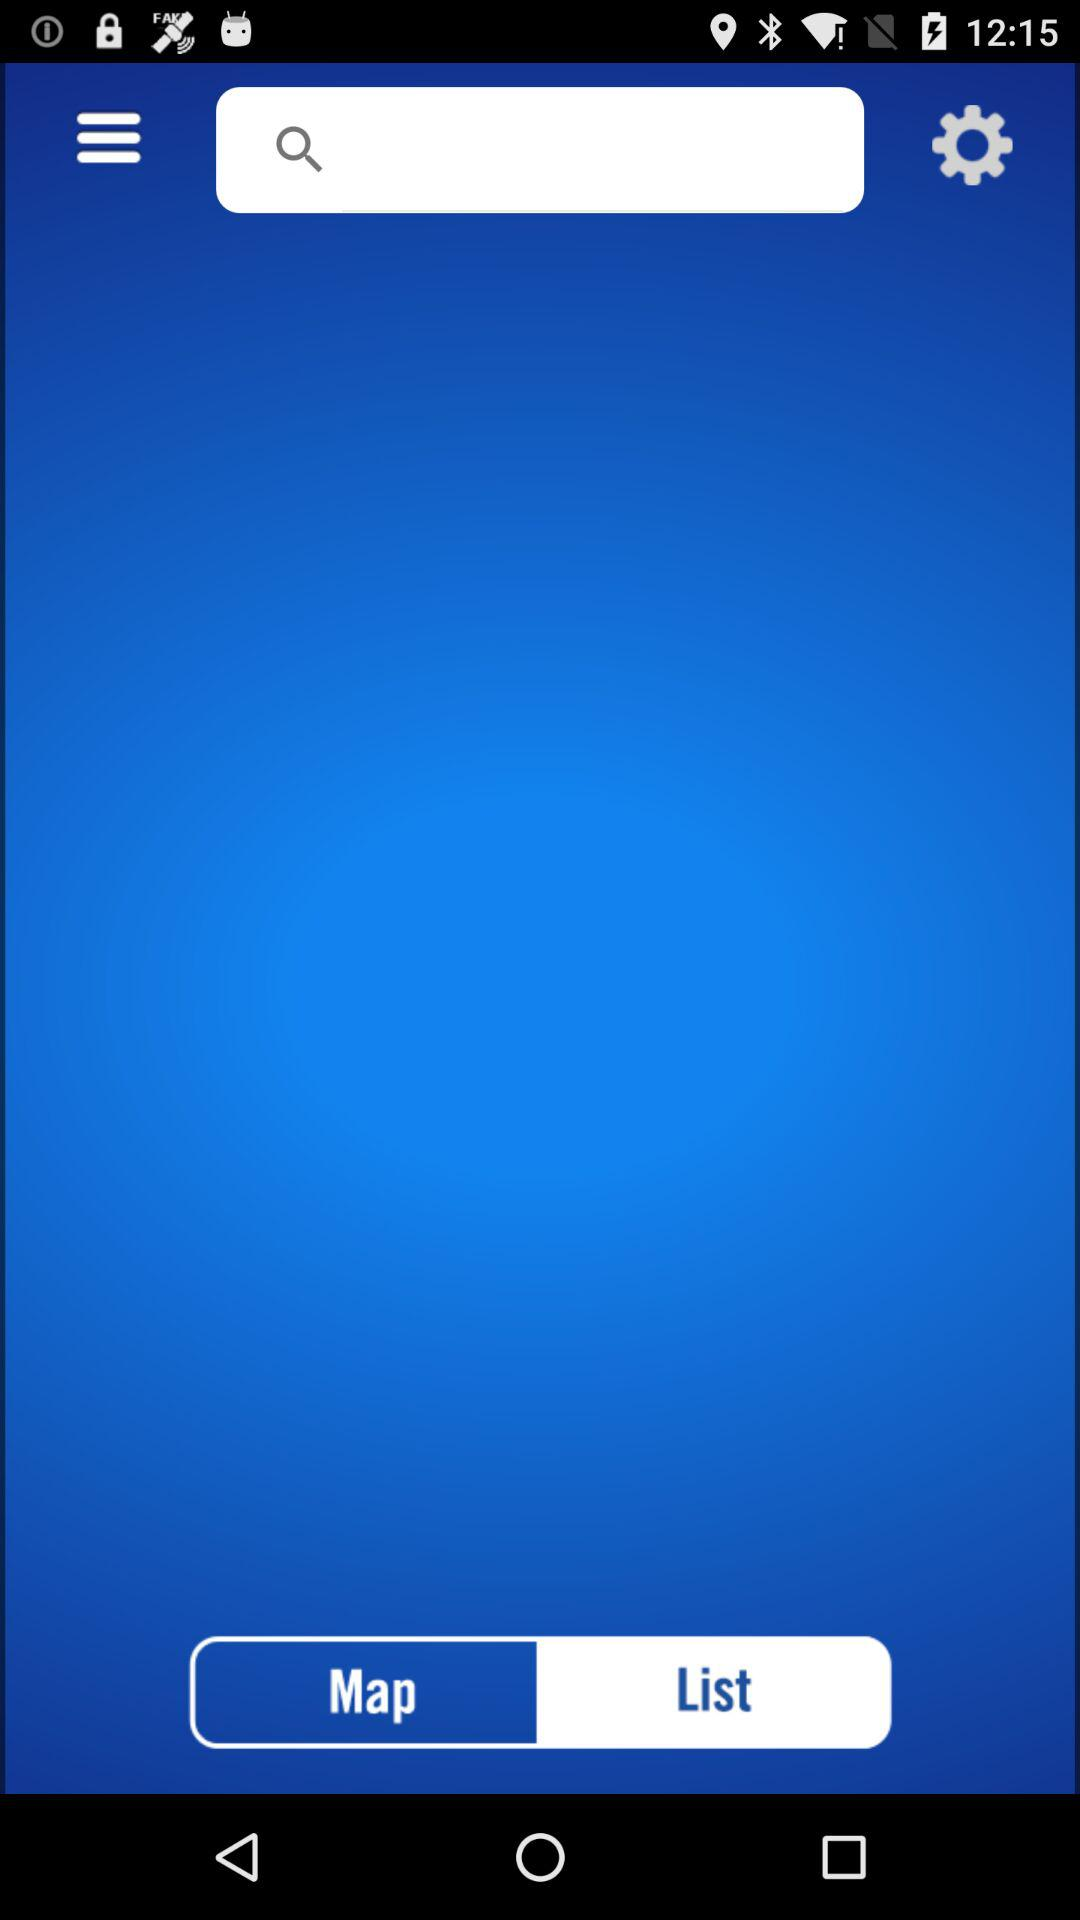Which tab is selected? The selected tab is "Map". 